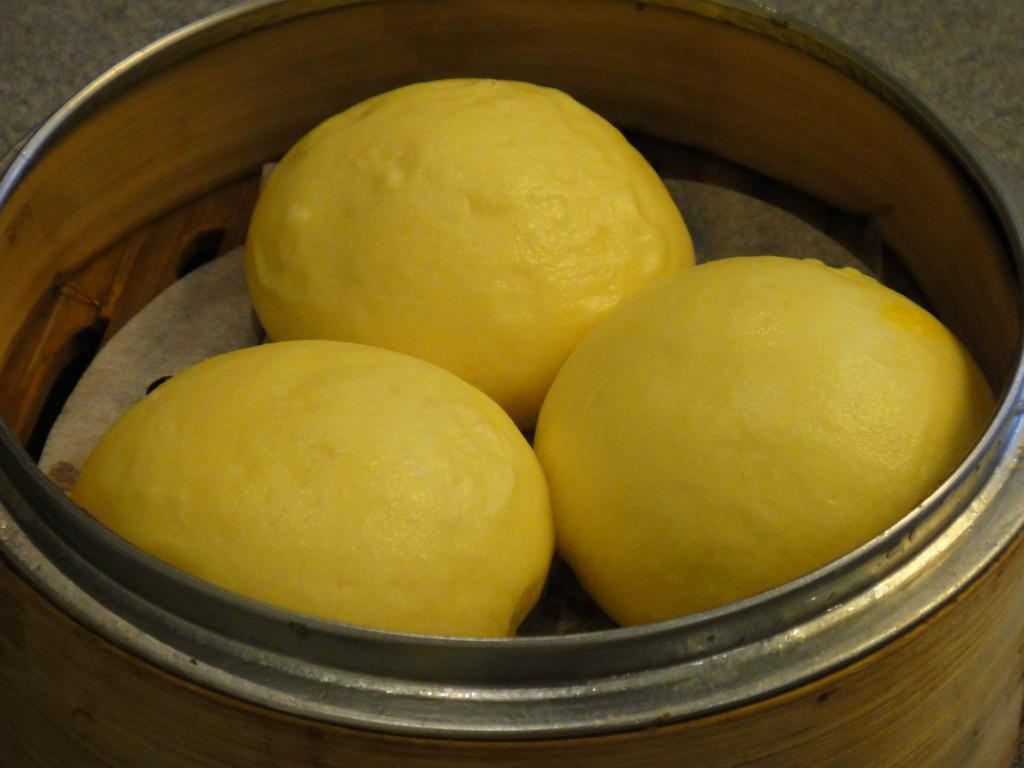What is in the image? There is a bowl in the image. What is inside the bowl? There are three lemons in the bowl. Where is the baby sleeping in the image? There is no baby present in the image; it only features a bowl with three lemons. 